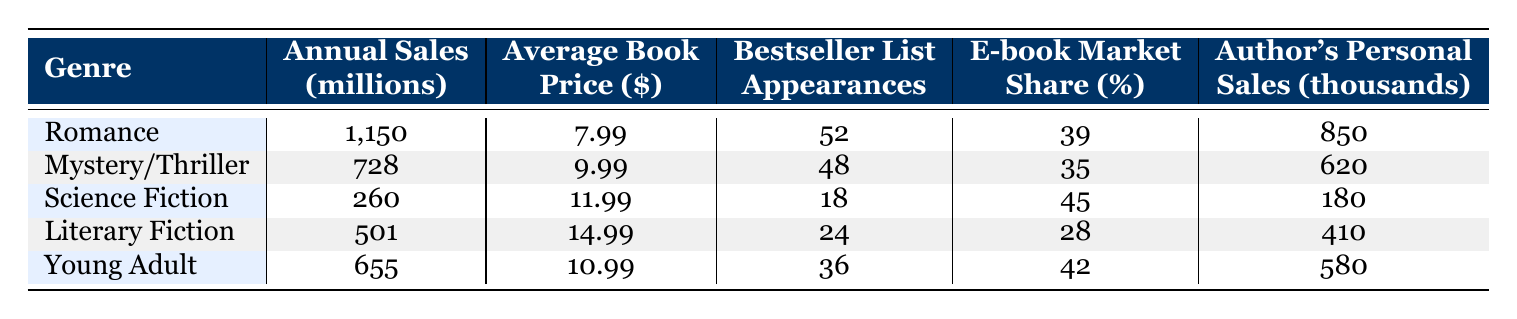What is the annual sales figure for the Romance genre? The table shows that the annual sales for the Romance genre is listed as 1,150 million.
Answer: 1,150 million Which genre has the highest average book price? By observing the average book price column, Literary Fiction has the highest price listed at 14.99 dollars.
Answer: Literary Fiction What is the difference in bestseller list appearances between Mystery/Thriller and Young Adult? Mystery/Thriller has 48 appearances and Young Adult has 36. The difference is 48 - 36 = 12.
Answer: 12 Is the E-book market share for Science Fiction genre greater than that for Mystery/Thriller? Science Fiction has an E-book market share of 45%, while Mystery/Thriller has 35%. Since 45% is greater than 35%, the statement is true.
Answer: Yes What is the total annual sales for Romance and Young Adult genres combined? For Romance, annual sales are 1,150 million and for Young Adult, it is 655 million. Adding them gives 1,150 + 655 = 1,805 million.
Answer: 1,805 million What percentage of the total bestseller appearances does the Romance genre contribute? The total bestseller appearances are 52 (Romance) + 48 (Mystery/Thriller) + 18 (Science Fiction) + 24 (Literary Fiction) + 36 (Young Adult) = 178. Romance contributes 52 to this total, (52 / 178) * 100 = 29.2%.
Answer: 29.2% Which genre has more personal sales: Young Adult or Science Fiction? Young Adult has personal sales of 580, while Science Fiction has 180. Since 580 is greater than 180, Young Adult has more personal sales.
Answer: Young Adult What is the average annual sales of the genres listed? The annual sales figures are 1,150 (Romance), 728 (Mystery/Thriller), 260 (Science Fiction), 501 (Literary Fiction), and 655 (Young Adult). The total is 1,150 + 728 + 260 + 501 + 655 = 3,294 million. There are 5 genres, so the average is 3,294 / 5 = 658.8 million.
Answer: 658.8 million Does the Mystery/Thriller genre have higher average book price compared to Young Adult? Mystery/Thriller has an average book price of 9.99 dollars, while Young Adult has 10.99 dollars. Since 9.99 is less than 10.99, this statement is false.
Answer: No 